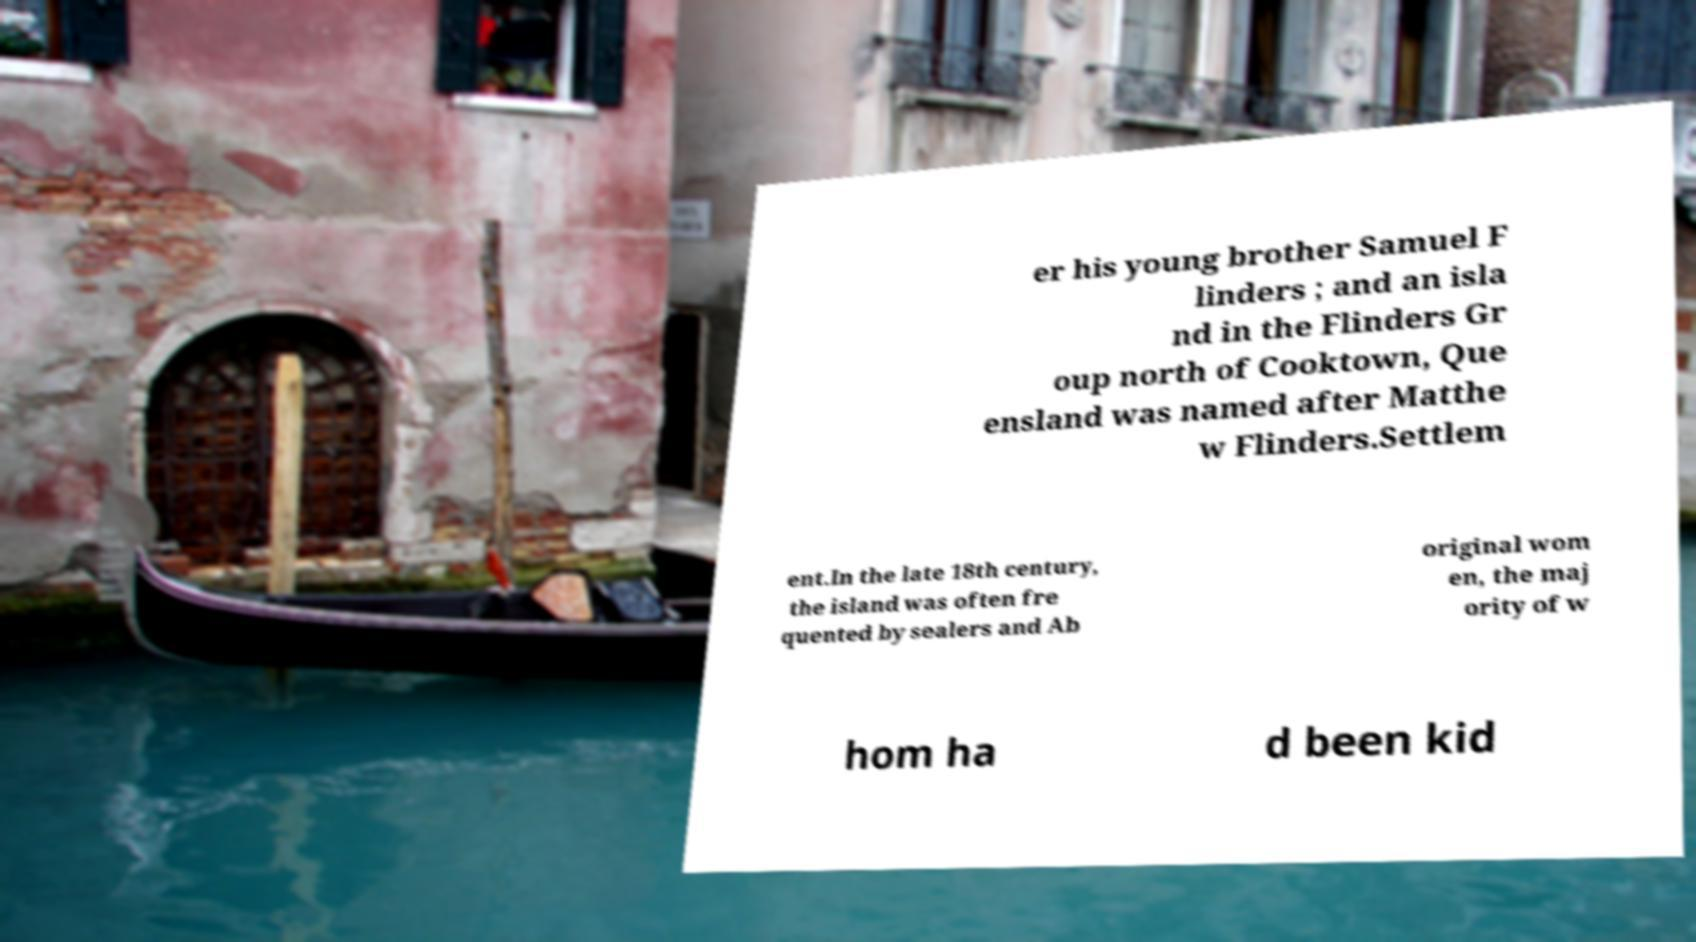There's text embedded in this image that I need extracted. Can you transcribe it verbatim? er his young brother Samuel F linders ; and an isla nd in the Flinders Gr oup north of Cooktown, Que ensland was named after Matthe w Flinders.Settlem ent.In the late 18th century, the island was often fre quented by sealers and Ab original wom en, the maj ority of w hom ha d been kid 